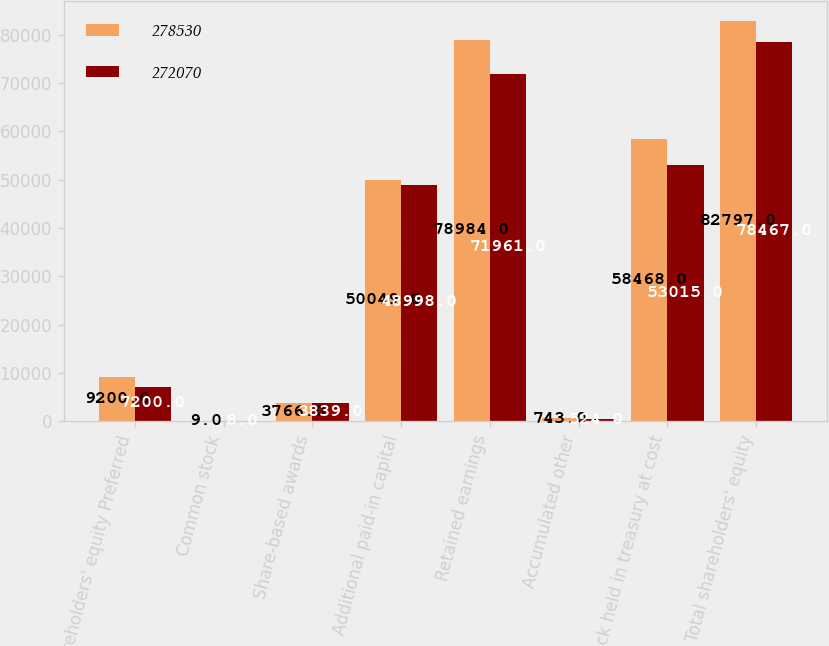<chart> <loc_0><loc_0><loc_500><loc_500><stacked_bar_chart><ecel><fcel>Shareholders' equity Preferred<fcel>Common stock<fcel>Share-based awards<fcel>Additional paid-in capital<fcel>Retained earnings<fcel>Accumulated other<fcel>Stock held in treasury at cost<fcel>Total shareholders' equity<nl><fcel>278530<fcel>9200<fcel>9<fcel>3766<fcel>50049<fcel>78984<fcel>743<fcel>58468<fcel>82797<nl><fcel>272070<fcel>7200<fcel>8<fcel>3839<fcel>48998<fcel>71961<fcel>524<fcel>53015<fcel>78467<nl></chart> 